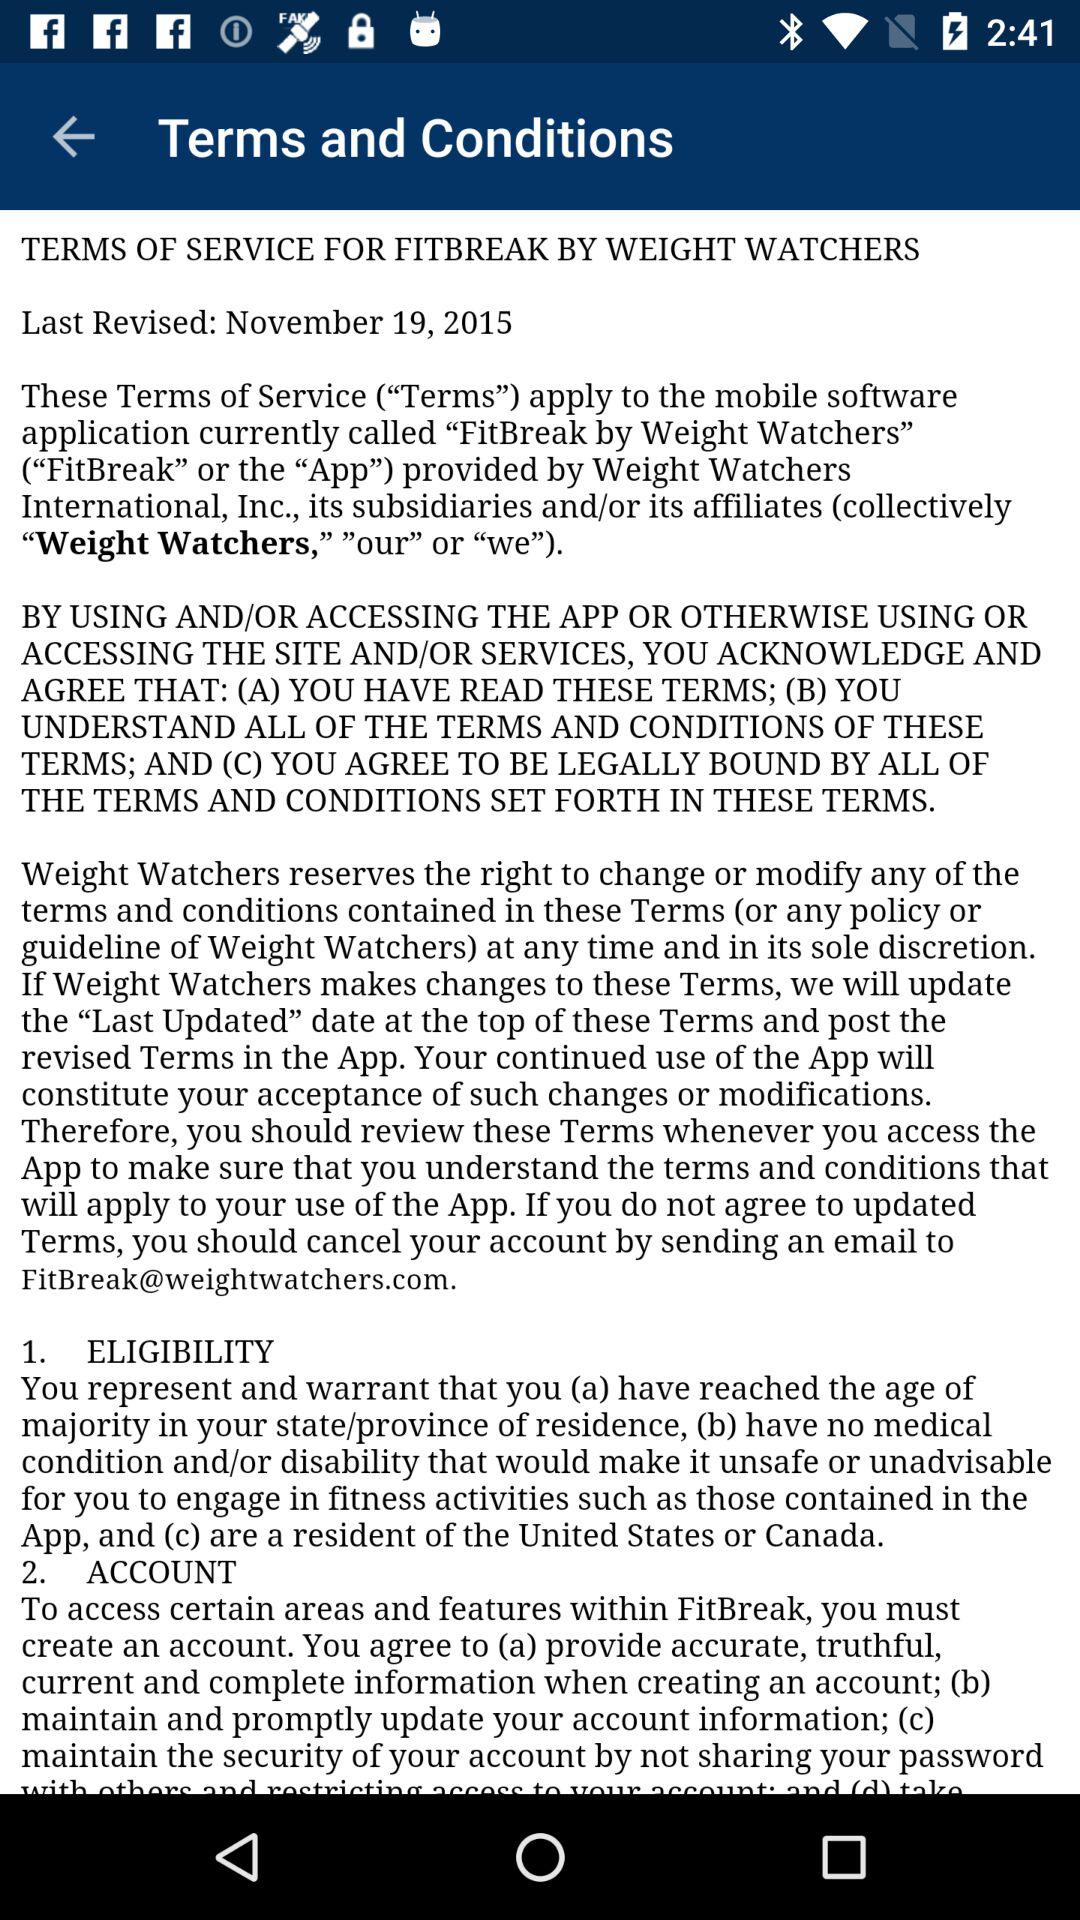On what date were the terms and conditions last revised? The terms and conditions were last revised on November 19, 2015. 